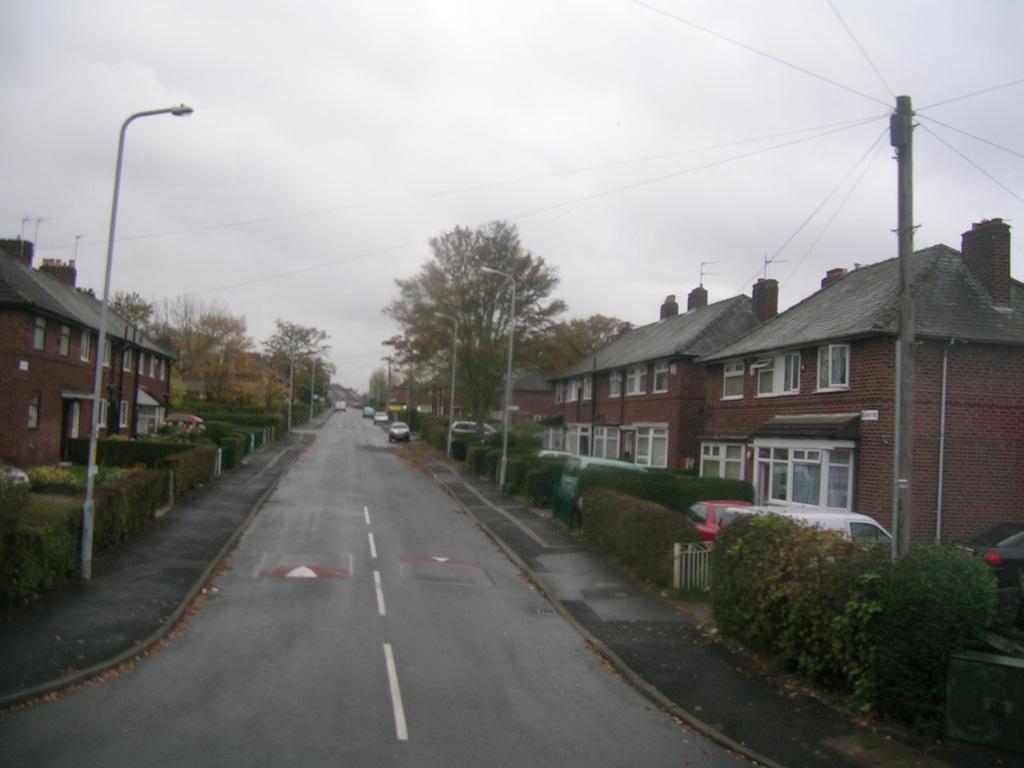Can you describe this image briefly? This picture is clicked outside. In the center we can see the road and we can see the vehicles. On both the sides we can see the houses, poles, lampposts cables, plants, trees and some other objects. In the background we can see the sky and the trees and buildings. 